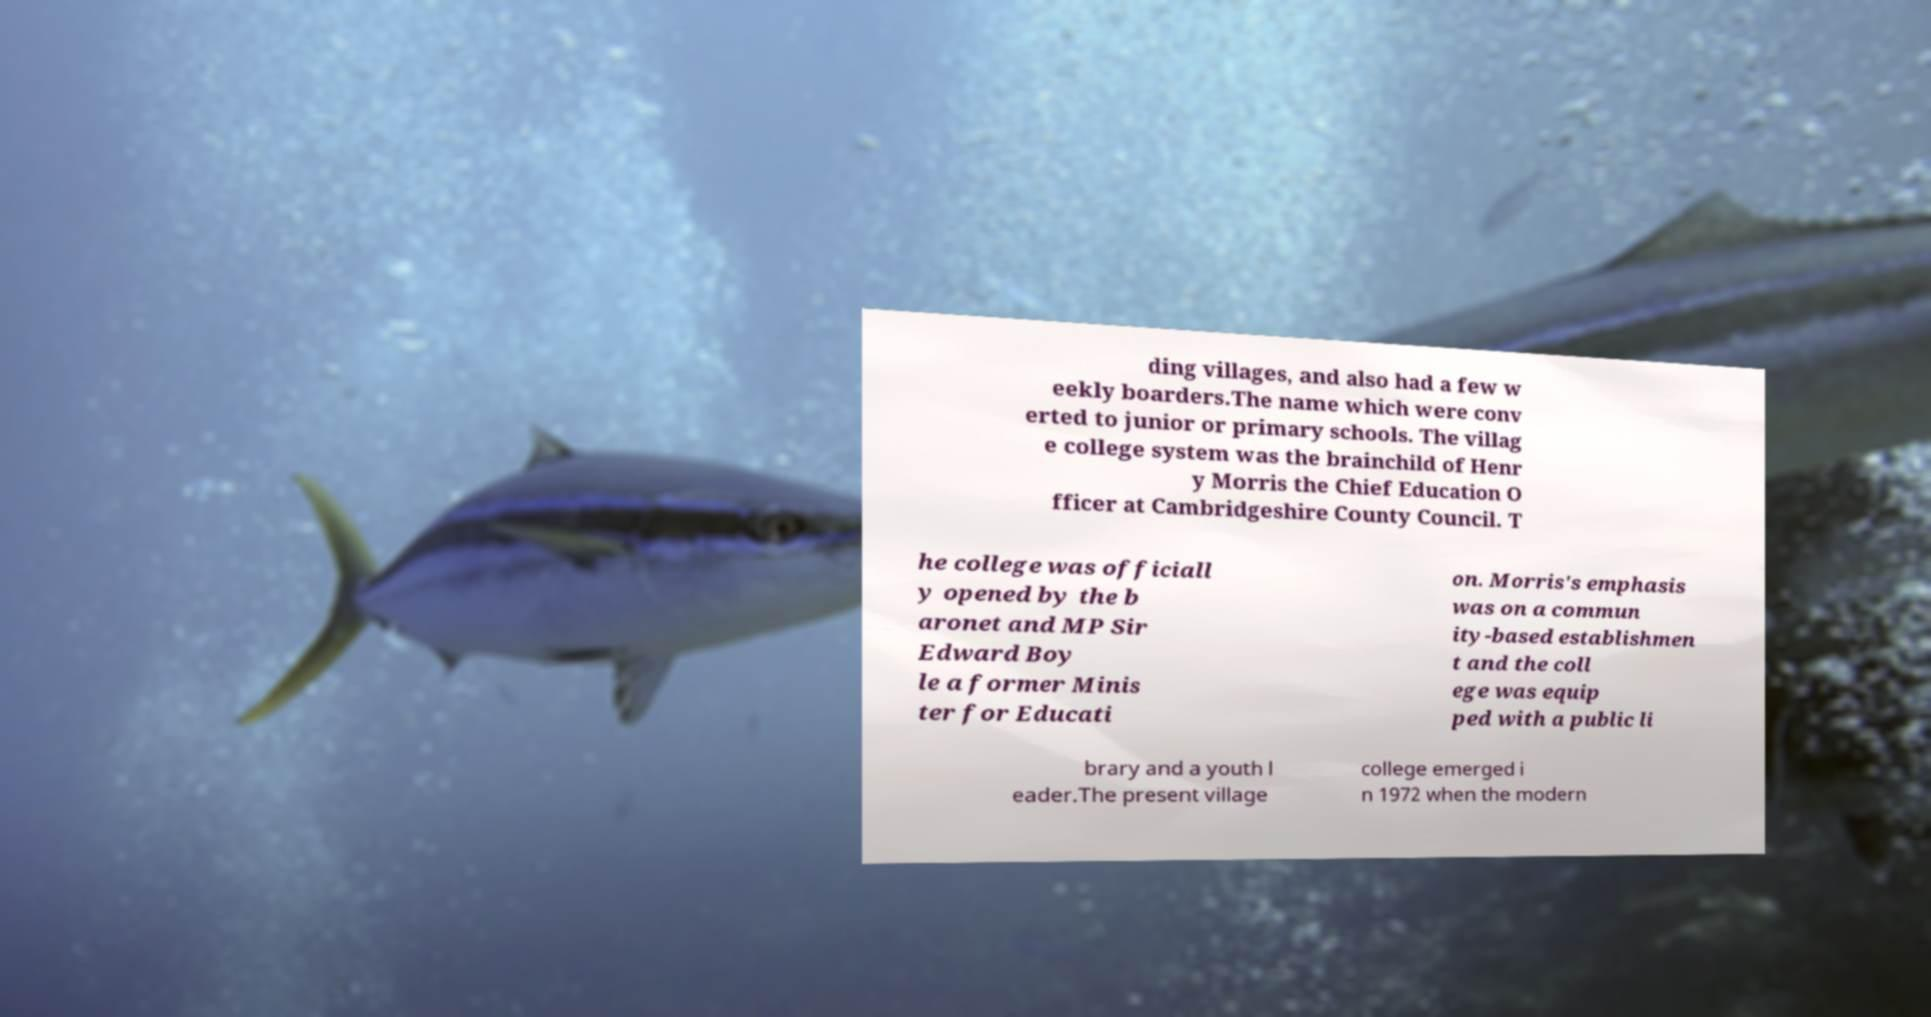Can you read and provide the text displayed in the image?This photo seems to have some interesting text. Can you extract and type it out for me? ding villages, and also had a few w eekly boarders.The name which were conv erted to junior or primary schools. The villag e college system was the brainchild of Henr y Morris the Chief Education O fficer at Cambridgeshire County Council. T he college was officiall y opened by the b aronet and MP Sir Edward Boy le a former Minis ter for Educati on. Morris's emphasis was on a commun ity-based establishmen t and the coll ege was equip ped with a public li brary and a youth l eader.The present village college emerged i n 1972 when the modern 